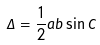<formula> <loc_0><loc_0><loc_500><loc_500>\Delta = \frac { 1 } { 2 } a b \sin C</formula> 